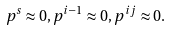Convert formula to latex. <formula><loc_0><loc_0><loc_500><loc_500>p ^ { s } \approx 0 , p ^ { i - 1 } \approx 0 , p ^ { i j } \approx 0 .</formula> 